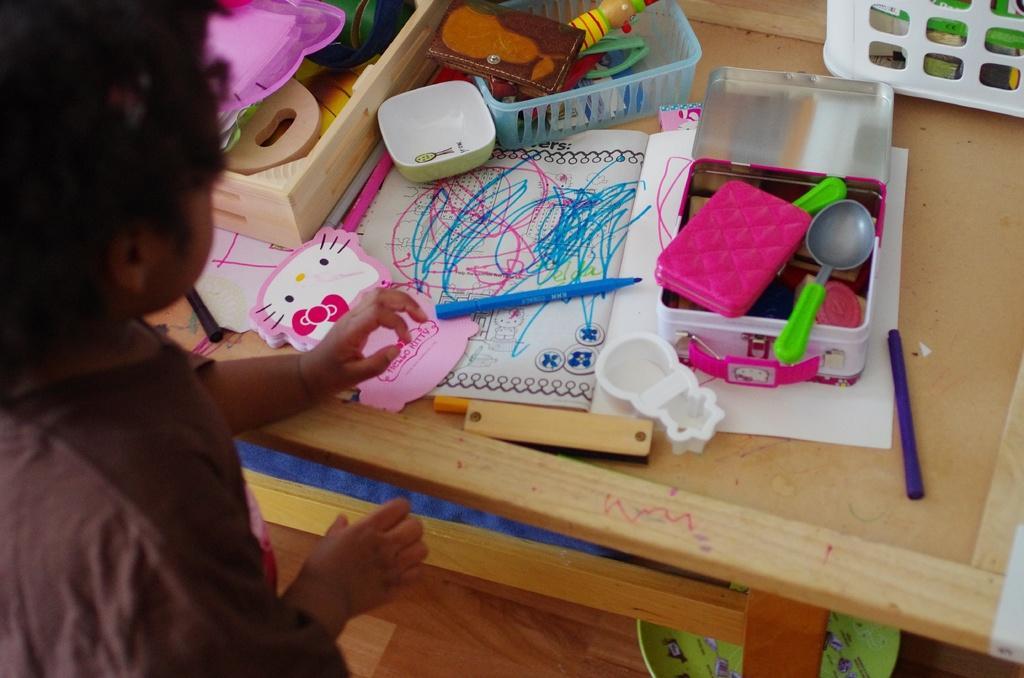Can you describe this image briefly? In this picture we can see child playing with some toys placed on a table such as spoon, box, bowl, purse, watch and below the table there is plate. 